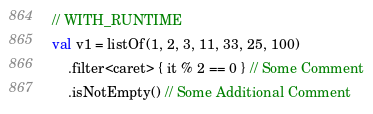Convert code to text. <code><loc_0><loc_0><loc_500><loc_500><_Kotlin_>// WITH_RUNTIME
val v1 = listOf(1, 2, 3, 11, 33, 25, 100)
    .filter<caret> { it % 2 == 0 } // Some Comment
    .isNotEmpty() // Some Additional Comment</code> 